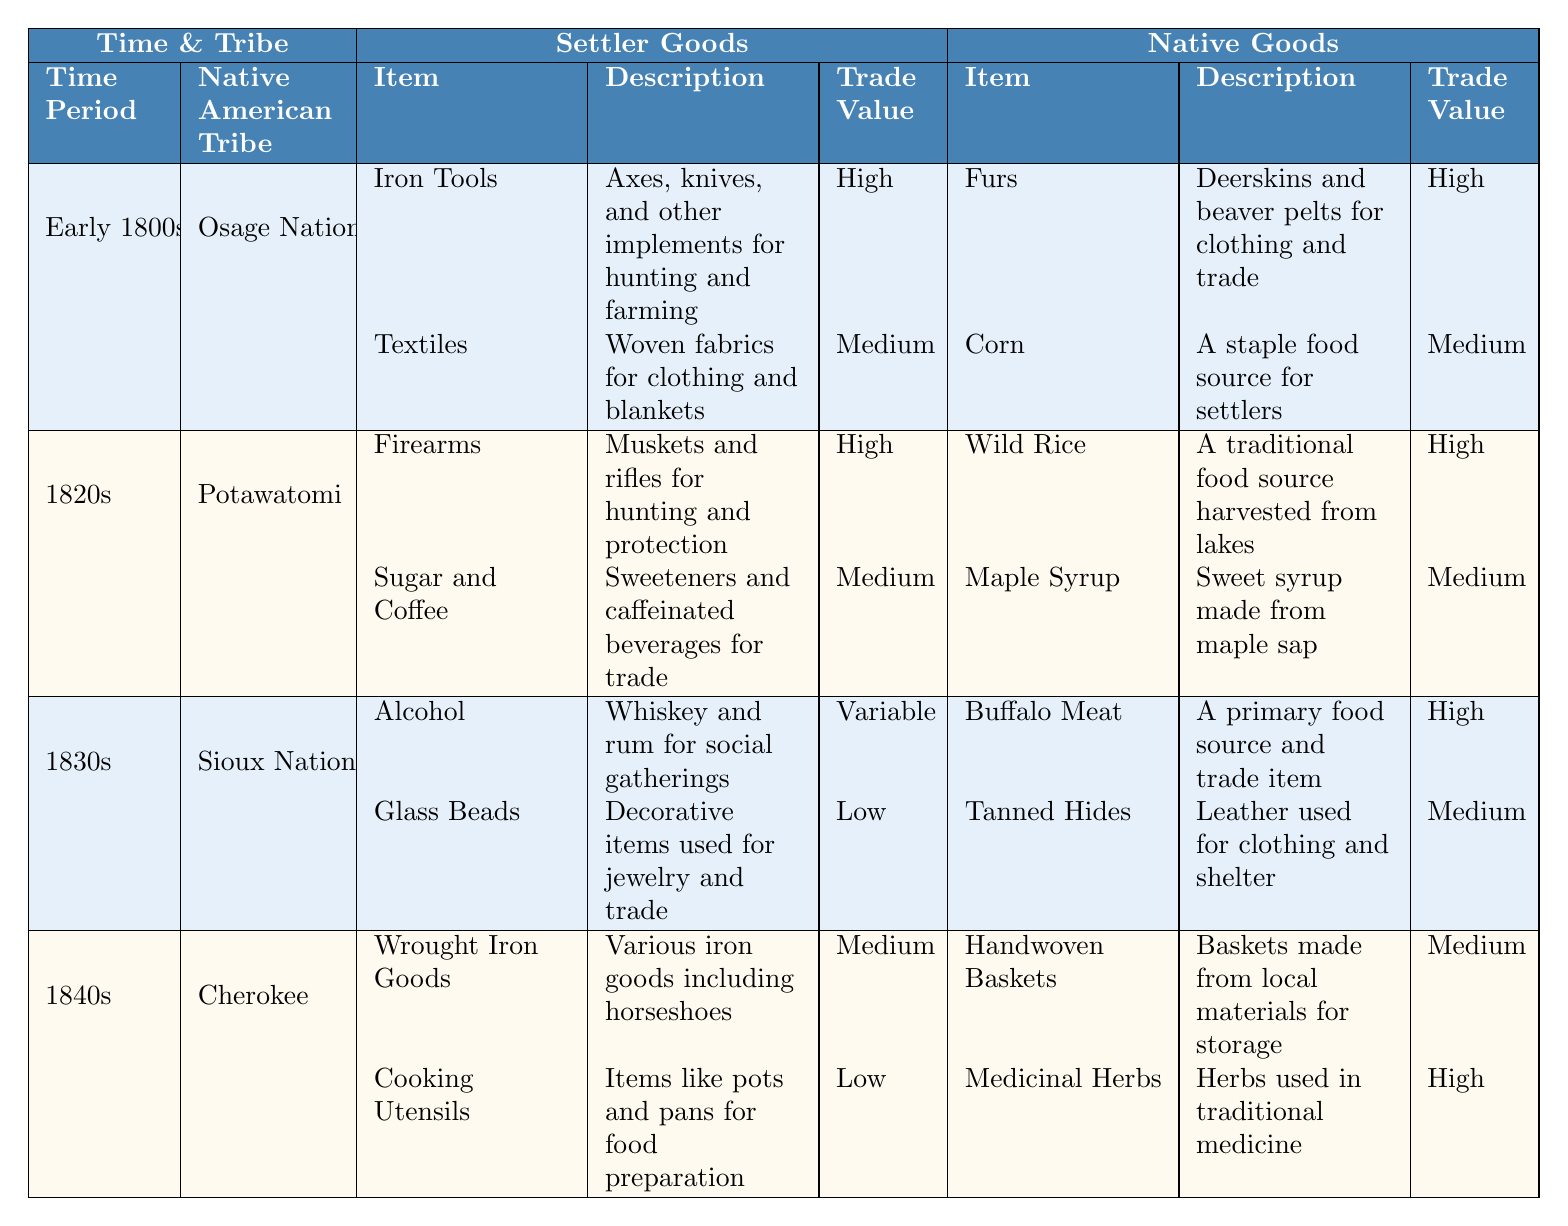What Native American tribe traded furs in the early 1800s? According to the table, the Osage Nation traded furs during the early 1800s.
Answer: Osage Nation Which item had a high trade value and was harvested from lakes? The table lists wild rice as having a high trade value and being harvested from lakes, associated with the Potawatomi tribe in the 1820s.
Answer: Wild Rice How many types of settler goods were listed for the Sioux Nation in the 1830s? The table indicates that there are two types of settler goods listed for the Sioux Nation during the 1830s: Alcohol and Glass Beads.
Answer: 2 What was the lowest trade value item traded by settlers in the 1840s? In the 1840s, the cooking utensils had the lowest trade value according to the table.
Answer: Cooking Utensils Which tribe had the highest number of high trade value goods exchanged in the early 1800s? The table shows that the Osage Nation had two high trade value goods (Iron Tools and Furs) compared to other tribes, but it is necessary to check other tribes to confirm. The Potawatomi also had two high trade value items (Firearms and Wild Rice). Thus, both have the highest.
Answer: Osage Nation and Potawatomi What is the trade value of textiles provided by the Osage Nation? Looking at the table, textiles provided by the Osage Nation had a medium trade value.
Answer: Medium How did the trade values of settler goods for the Sioux Nation compare to the trade values of their native goods? The settler goods for the Sioux Nation included one variable value (Alcohol) and one low value (Glass Beads). Both their native goods (Buffalo Meat and Tanned Hides) included one high and one medium value. Thus, the overall value of native goods was higher.
Answer: Native goods were higher What is the difference in trade value classification between the most valuable item traded by settlers in the 1840s and the least valuable item traded by settlers in the 1830s? The most valuable item traded by settlers in the 1840s is Wrought Iron Goods with a medium trade value, while the least valuable item in the 1830s is Glass Beads with a low trade value. The difference in classification is medium versus low, which is one classification level apart.
Answer: One classification level apart Which goods did the Potawatomi and Sioux nations trade that could be classified as traditional food sources? According to the table, the Potawatomi traded wild rice and the Sioux traded buffalo meat as traditional food sources.
Answer: Wild Rice and Buffalo Meat 